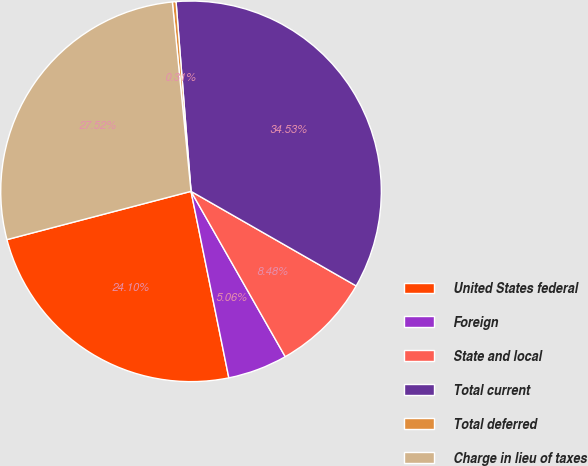Convert chart. <chart><loc_0><loc_0><loc_500><loc_500><pie_chart><fcel>United States federal<fcel>Foreign<fcel>State and local<fcel>Total current<fcel>Total deferred<fcel>Charge in lieu of taxes<nl><fcel>24.1%<fcel>5.06%<fcel>8.48%<fcel>34.53%<fcel>0.31%<fcel>27.52%<nl></chart> 